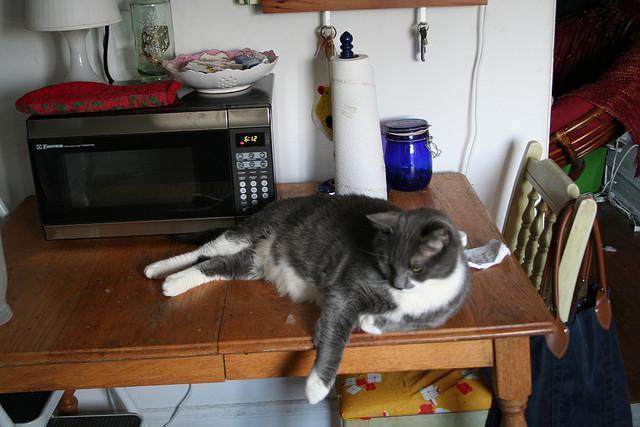What is illuminating the cat and the table?
Indicate the correct response and explain using: 'Answer: answer
Rationale: rationale.'
Options: Led light, halogen light, fluorescent light, sunlight. Answer: sunlight.
Rationale: Light is coming in from a window. 